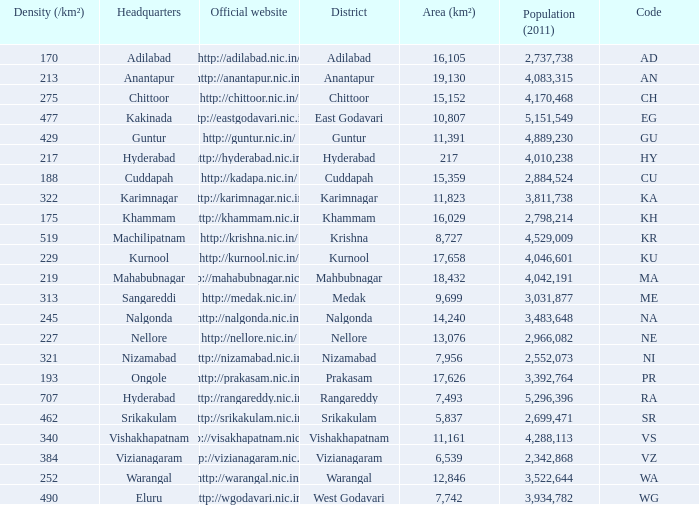What is the sum of the area values for districts having density over 462 and websites of http://krishna.nic.in/? 8727.0. 